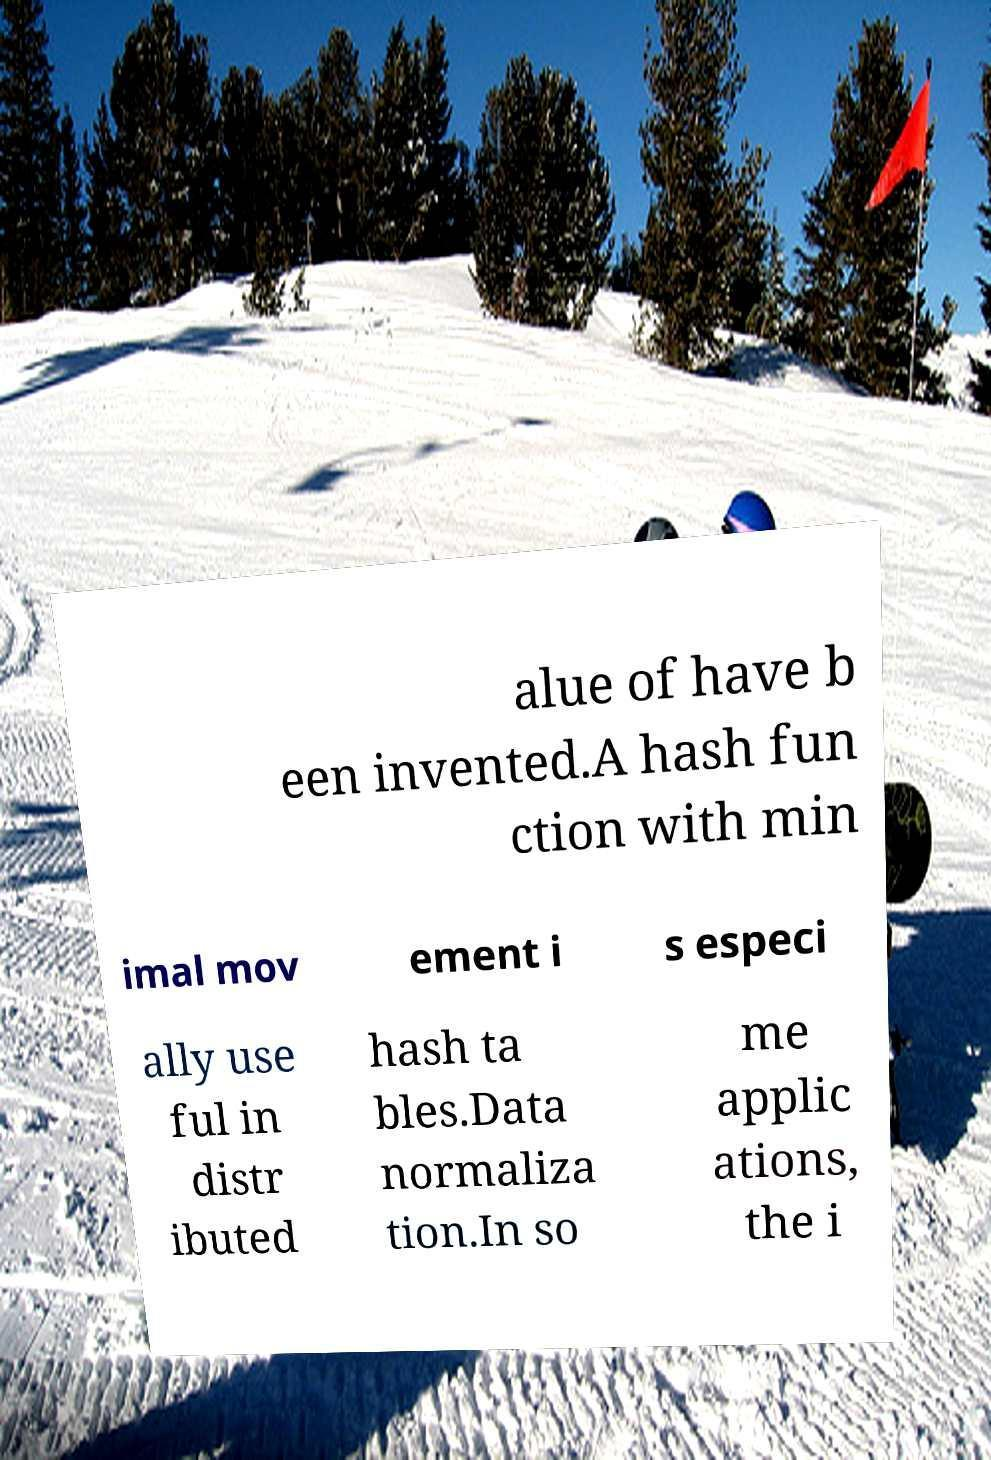There's text embedded in this image that I need extracted. Can you transcribe it verbatim? alue of have b een invented.A hash fun ction with min imal mov ement i s especi ally use ful in distr ibuted hash ta bles.Data normaliza tion.In so me applic ations, the i 